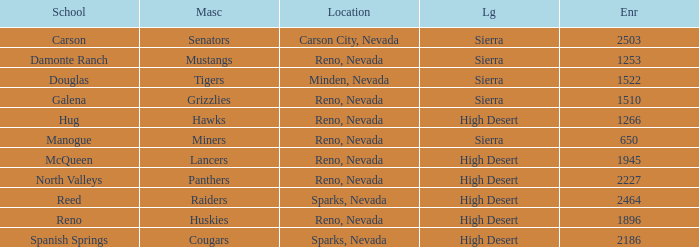What city and state are the miners located in? Reno, Nevada. 